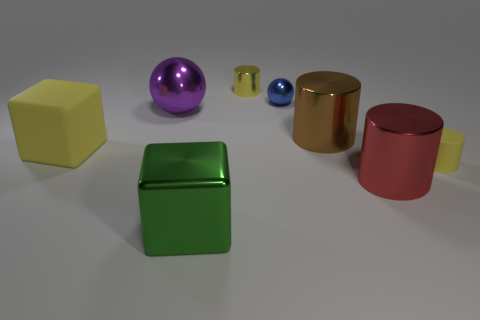How many shiny cylinders are both behind the brown thing and to the right of the brown cylinder? There are no shiny cylinders positioned both behind the brown block and to the right of the brown cylinder. The description of the scene is precise in terms of the spatial arrangement. The objects present don’t meet the criteria of being shiny cylinders with the specified locations. 